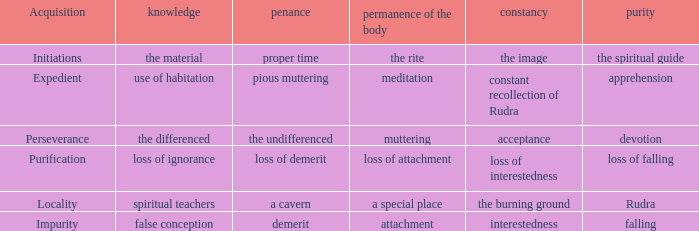What is the total number of constancy where purity is falling 1.0. 